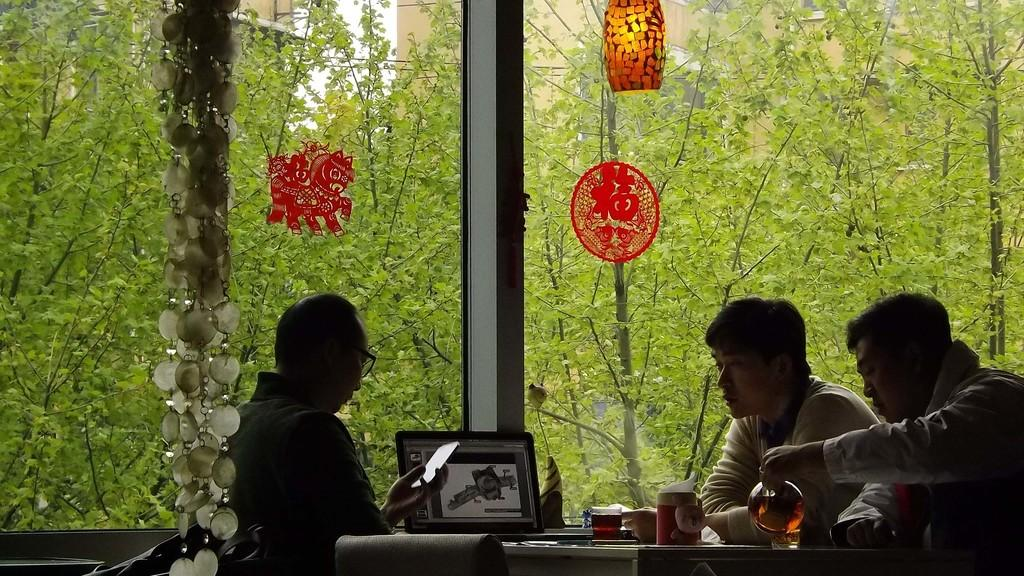How many people are in the image? There are three persons in the image. What are the persons doing in the image? The persons are sitting around a dining table. What type of walls can be seen in the image? There are glass walls in the image. What can be seen outside the glass walls? Trees are visible outside the glass walls. Who is the expert in the field of marine biology in the image? There is no indication in the image that any of the persons are experts in marine biology. What is the reason for the persons sitting around the dining table in the image? The image does not provide information about the reason for the persons sitting around the dining table. 